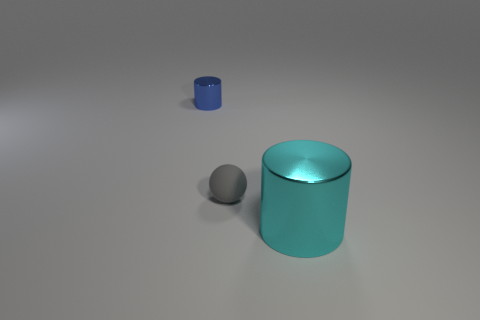Add 3 small yellow matte cylinders. How many objects exist? 6 Subtract 1 cylinders. How many cylinders are left? 1 Add 1 small blue cylinders. How many small blue cylinders are left? 2 Add 1 tiny gray rubber balls. How many tiny gray rubber balls exist? 2 Subtract 0 purple spheres. How many objects are left? 3 Subtract all cylinders. How many objects are left? 1 Subtract all brown spheres. Subtract all green cylinders. How many spheres are left? 1 Subtract all brown spheres. How many cyan cylinders are left? 1 Subtract all tiny purple blocks. Subtract all cylinders. How many objects are left? 1 